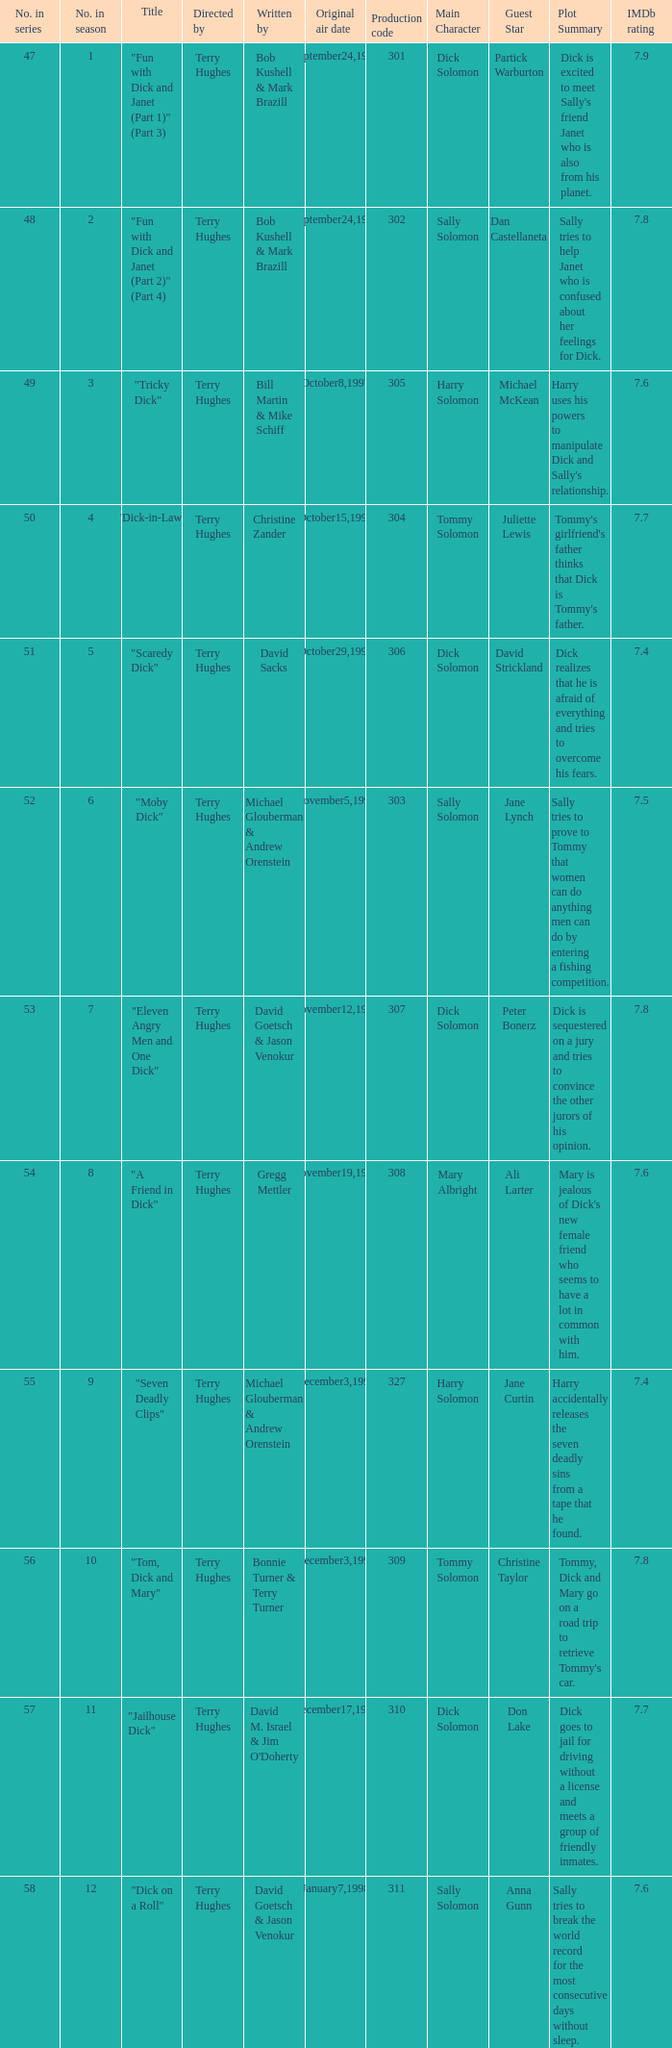What is the original air date of the episode with production code is 319? April1,1998. 